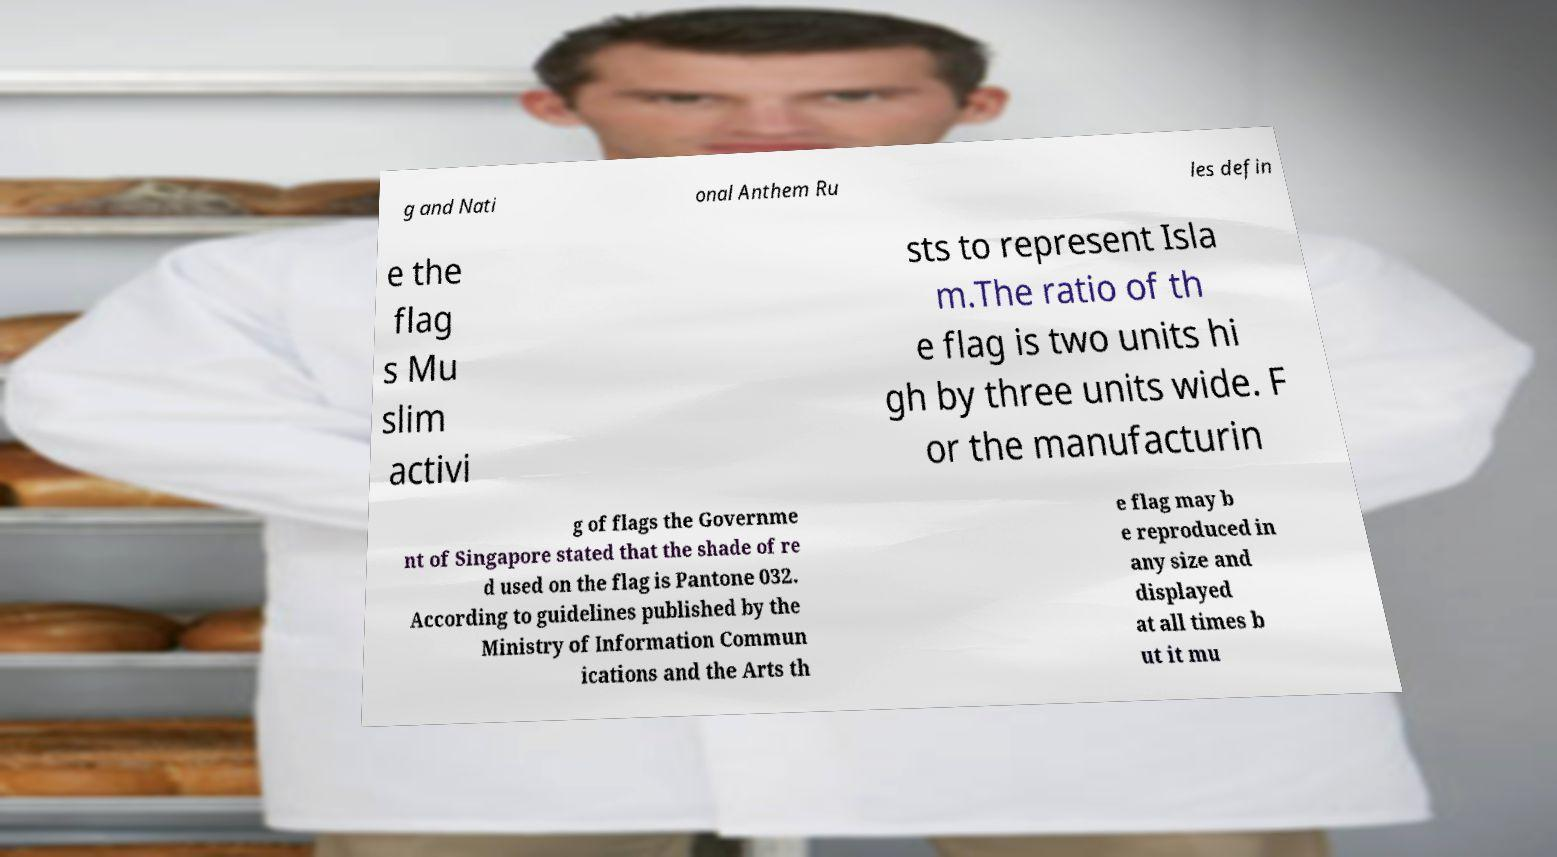I need the written content from this picture converted into text. Can you do that? g and Nati onal Anthem Ru les defin e the flag s Mu slim activi sts to represent Isla m.The ratio of th e flag is two units hi gh by three units wide. F or the manufacturin g of flags the Governme nt of Singapore stated that the shade of re d used on the flag is Pantone 032. According to guidelines published by the Ministry of Information Commun ications and the Arts th e flag may b e reproduced in any size and displayed at all times b ut it mu 